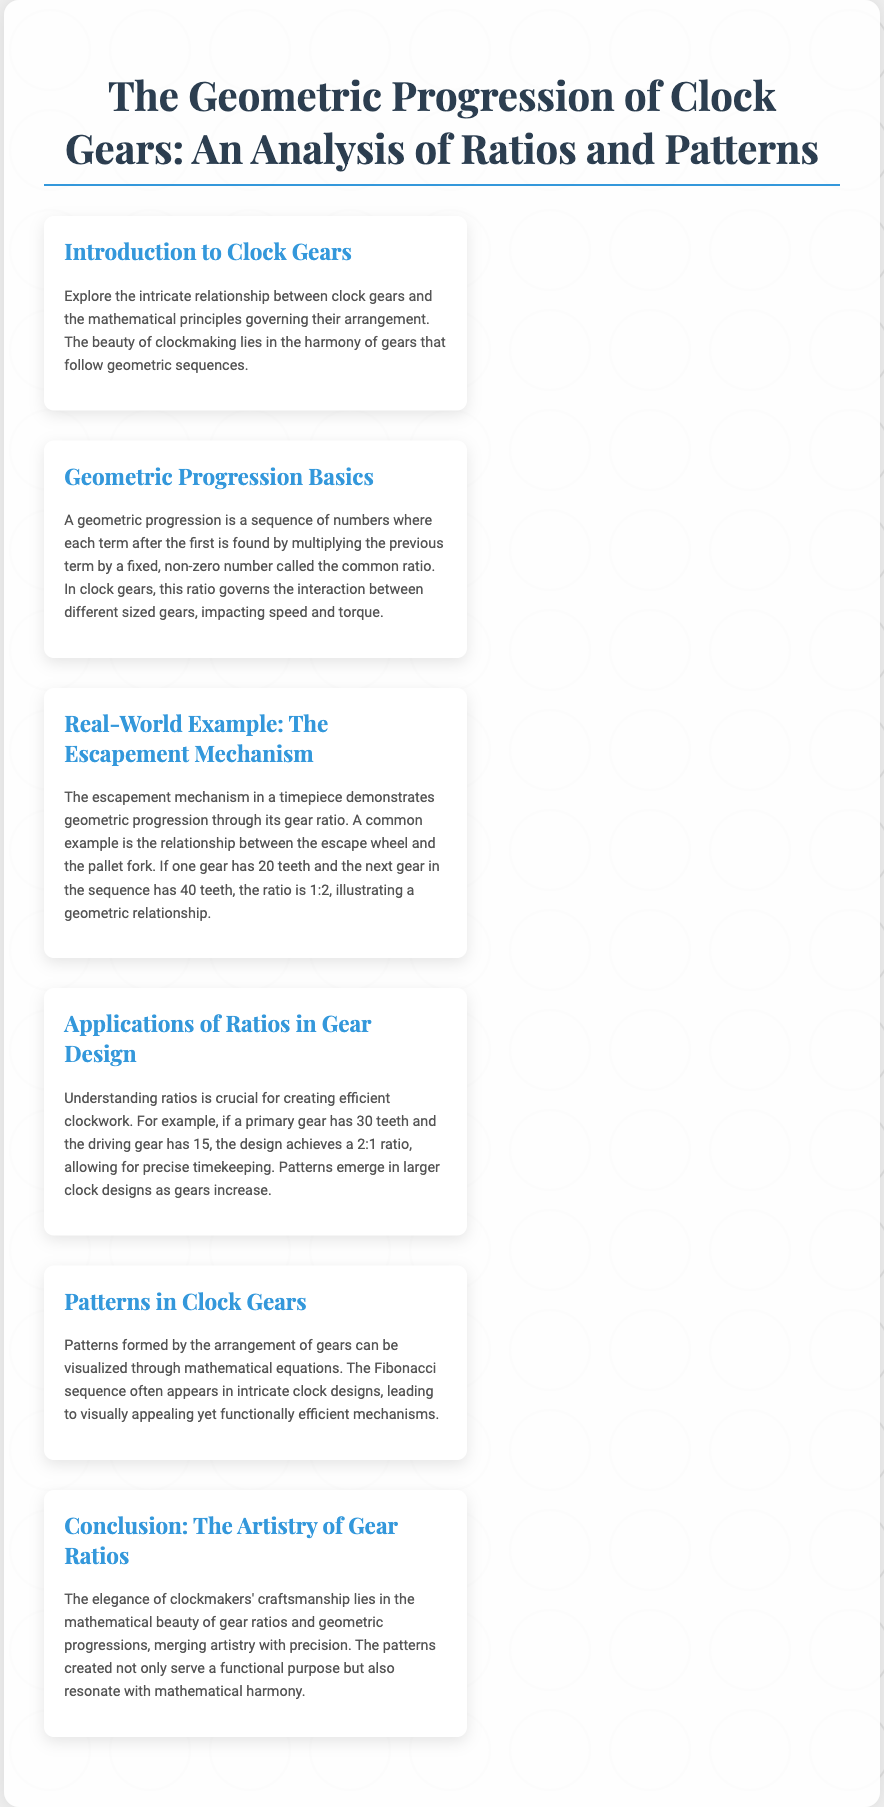What is the title of the document? The title is prominently displayed at the top of the document, summarizing the main theme.
Answer: The Geometric Progression of Clock Gears: An Analysis of Ratios and Patterns What is a geometric progression? The Basics section defines a geometric progression as a sequence where each term after the first is found by multiplying the previous term by a fixed number.
Answer: A sequence of numbers where each term is found by multiplying the previous term by a fixed ratio What is the gear ratio between the escape wheel and the pallet fork in the example? The Real-World Example refers to the teeth of the gears, noting a specific ratio between them.
Answer: 1:2 How many teeth does the primary gear have in the Applications section? The Applications section mentions the primary gear's tooth count specifically.
Answer: 30 teeth What mathematical sequence is mentioned in relation to clock designs? The Patterns section references a famous mathematical sequence that frequently appears in clock designs.
Answer: Fibonacci sequence What is the common ratio in the example given in the Real-World Example? The Real-World Example discusses gear teeth counts that establish a specific proportion.
Answer: 2 What is the significance of understanding ratios in gear design? The Applications section explains the importance of ratios in achieving precise timing within clock mechanisms.
Answer: Precise timekeeping What is the central theme of the Conclusion section? The Conclusion summarizes the overarching message of the document regarding craftsmanship in clockmaking.
Answer: The mathematical beauty of gear ratios and geometric progressions 